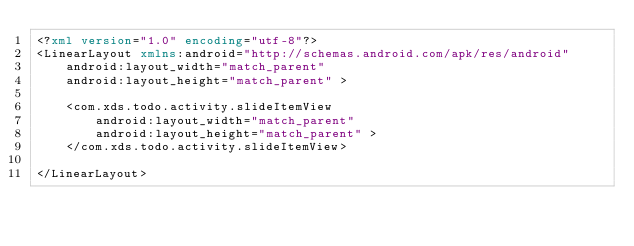Convert code to text. <code><loc_0><loc_0><loc_500><loc_500><_XML_><?xml version="1.0" encoding="utf-8"?>
<LinearLayout xmlns:android="http://schemas.android.com/apk/res/android"
    android:layout_width="match_parent"
    android:layout_height="match_parent" >

    <com.xds.todo.activity.slideItemView
        android:layout_width="match_parent"
        android:layout_height="match_parent" >
    </com.xds.todo.activity.slideItemView>

</LinearLayout></code> 